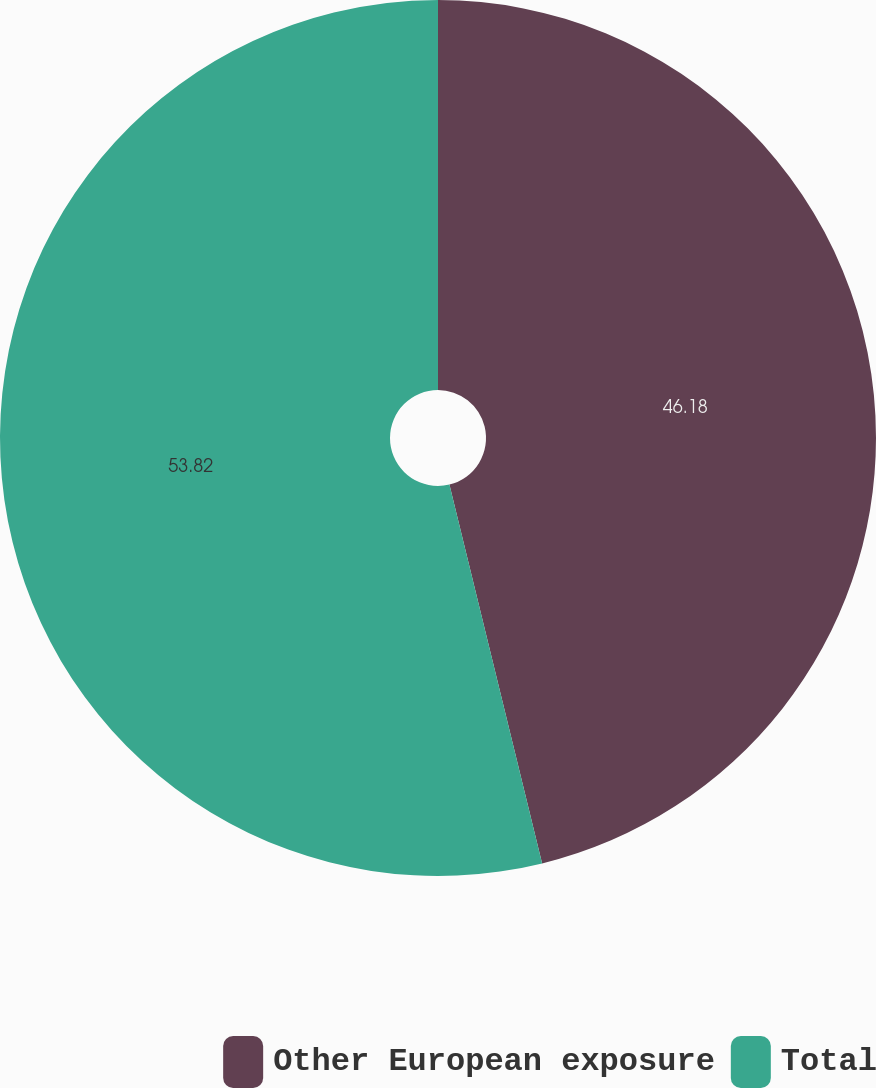Convert chart to OTSL. <chart><loc_0><loc_0><loc_500><loc_500><pie_chart><fcel>Other European exposure<fcel>Total<nl><fcel>46.18%<fcel>53.82%<nl></chart> 